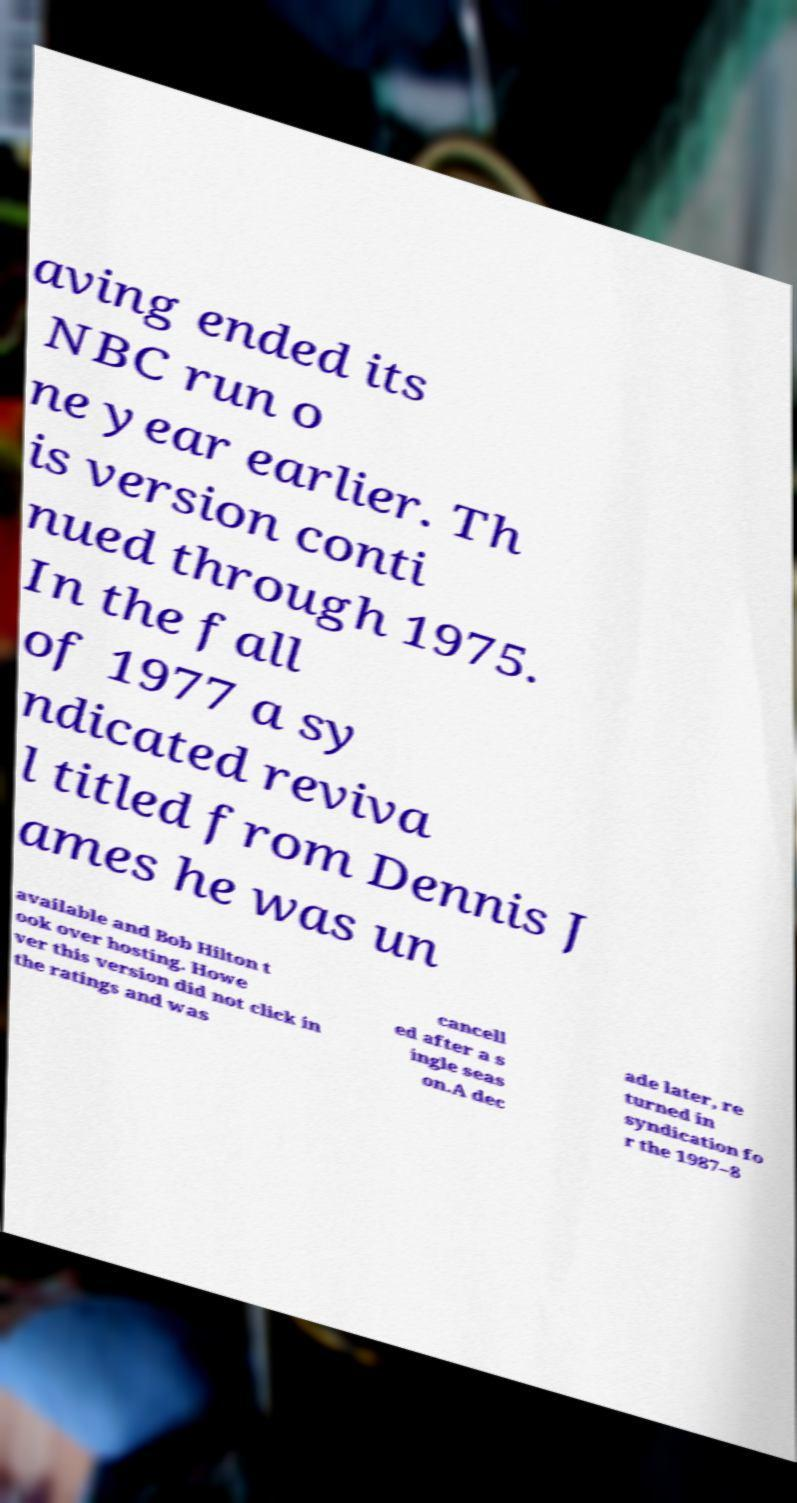Could you assist in decoding the text presented in this image and type it out clearly? aving ended its NBC run o ne year earlier. Th is version conti nued through 1975. In the fall of 1977 a sy ndicated reviva l titled from Dennis J ames he was un available and Bob Hilton t ook over hosting. Howe ver this version did not click in the ratings and was cancell ed after a s ingle seas on.A dec ade later, re turned in syndication fo r the 1987–8 